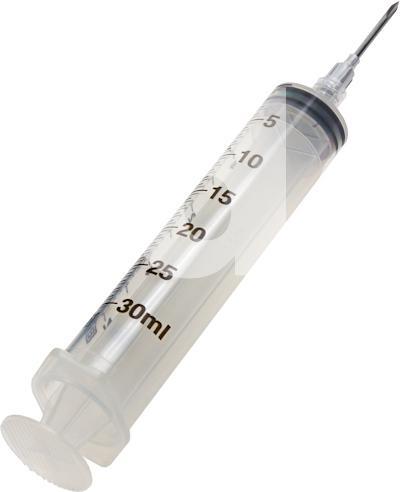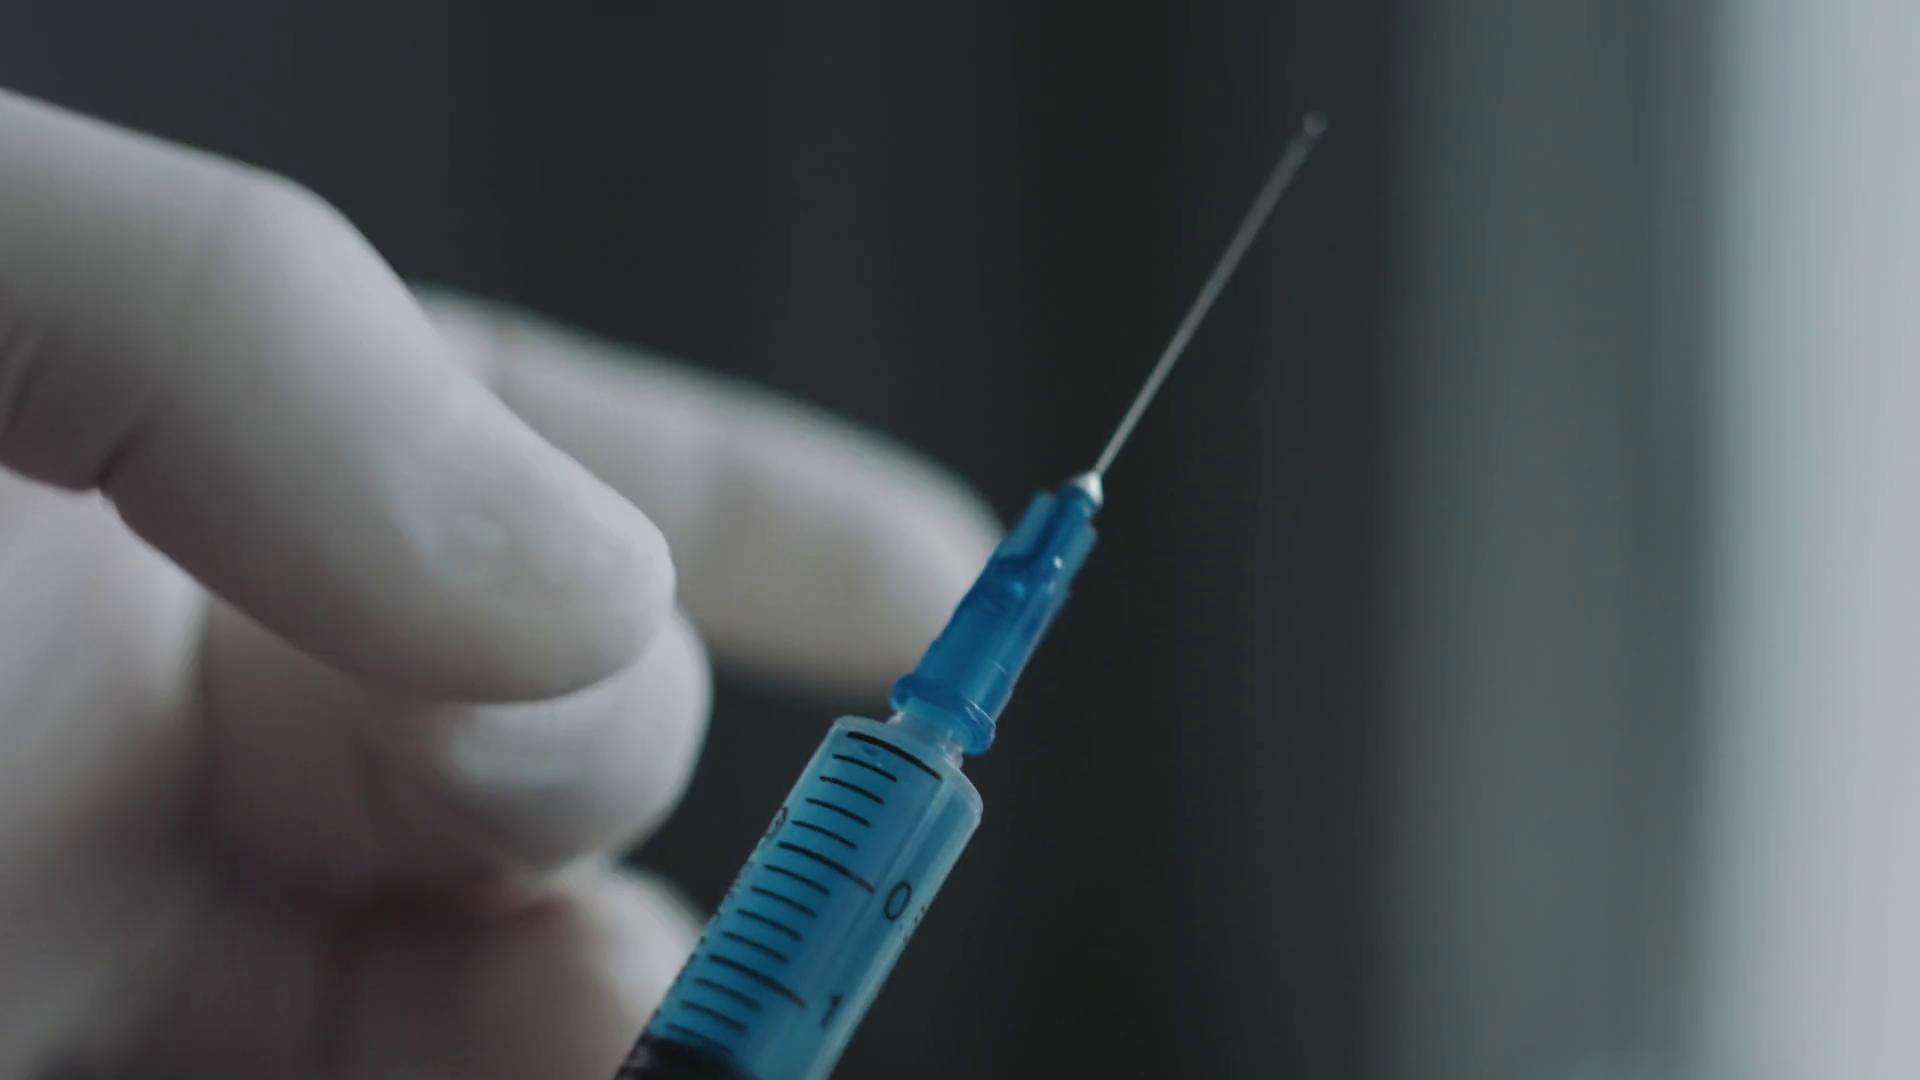The first image is the image on the left, the second image is the image on the right. Evaluate the accuracy of this statement regarding the images: "There are two needles with at least two blue gloves.". Is it true? Answer yes or no. No. The first image is the image on the left, the second image is the image on the right. Considering the images on both sides, is "Both syringes are pointed upwards." valid? Answer yes or no. Yes. 